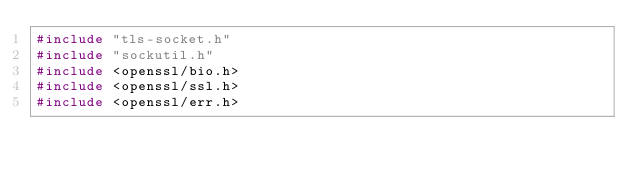<code> <loc_0><loc_0><loc_500><loc_500><_C_>#include "tls-socket.h"
#include "sockutil.h"
#include <openssl/bio.h>
#include <openssl/ssl.h>
#include <openssl/err.h></code> 